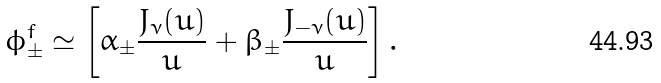<formula> <loc_0><loc_0><loc_500><loc_500>\phi _ { \pm } ^ { f } \simeq \left [ \alpha _ { \pm } { \frac { J _ { \nu } ( u ) } { u } } + \beta _ { \pm } { \frac { J _ { - \nu } ( u ) } { u } } \right ] .</formula> 